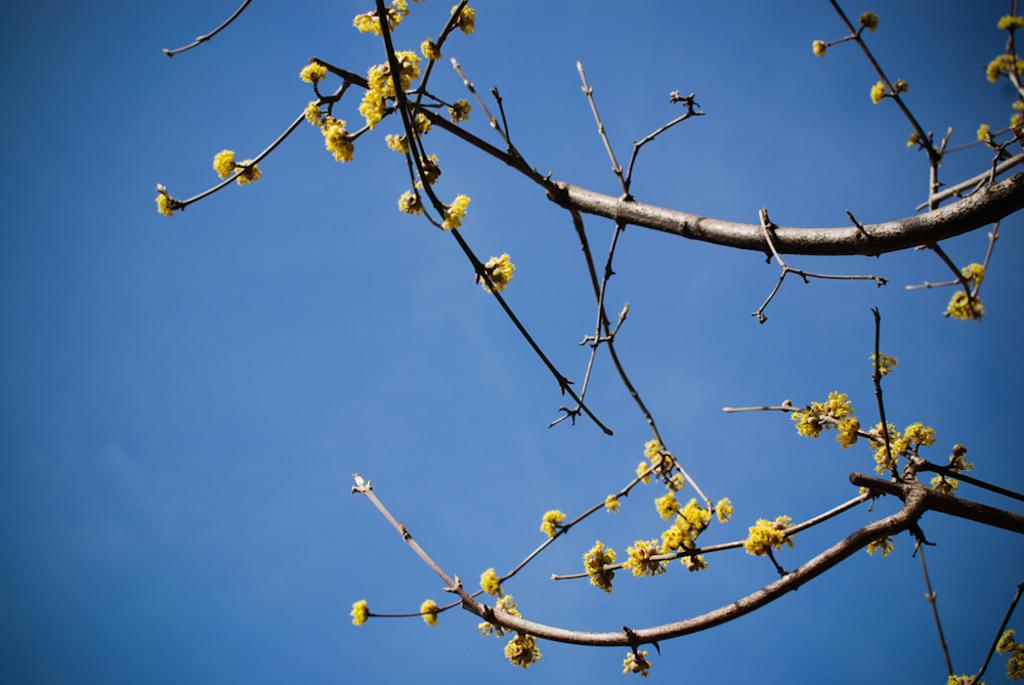What is the main subject of the image? There is a tree in the image. What can be observed about the tree's appearance? The tree has yellow flowers. What color is the sky in the background of the image? The sky is blue in the background of the image. What type of caption is written on the tree in the image? There is no caption written on the tree in the image. Can you tell me how many bones are visible in the image? There are no bones present in the image. 